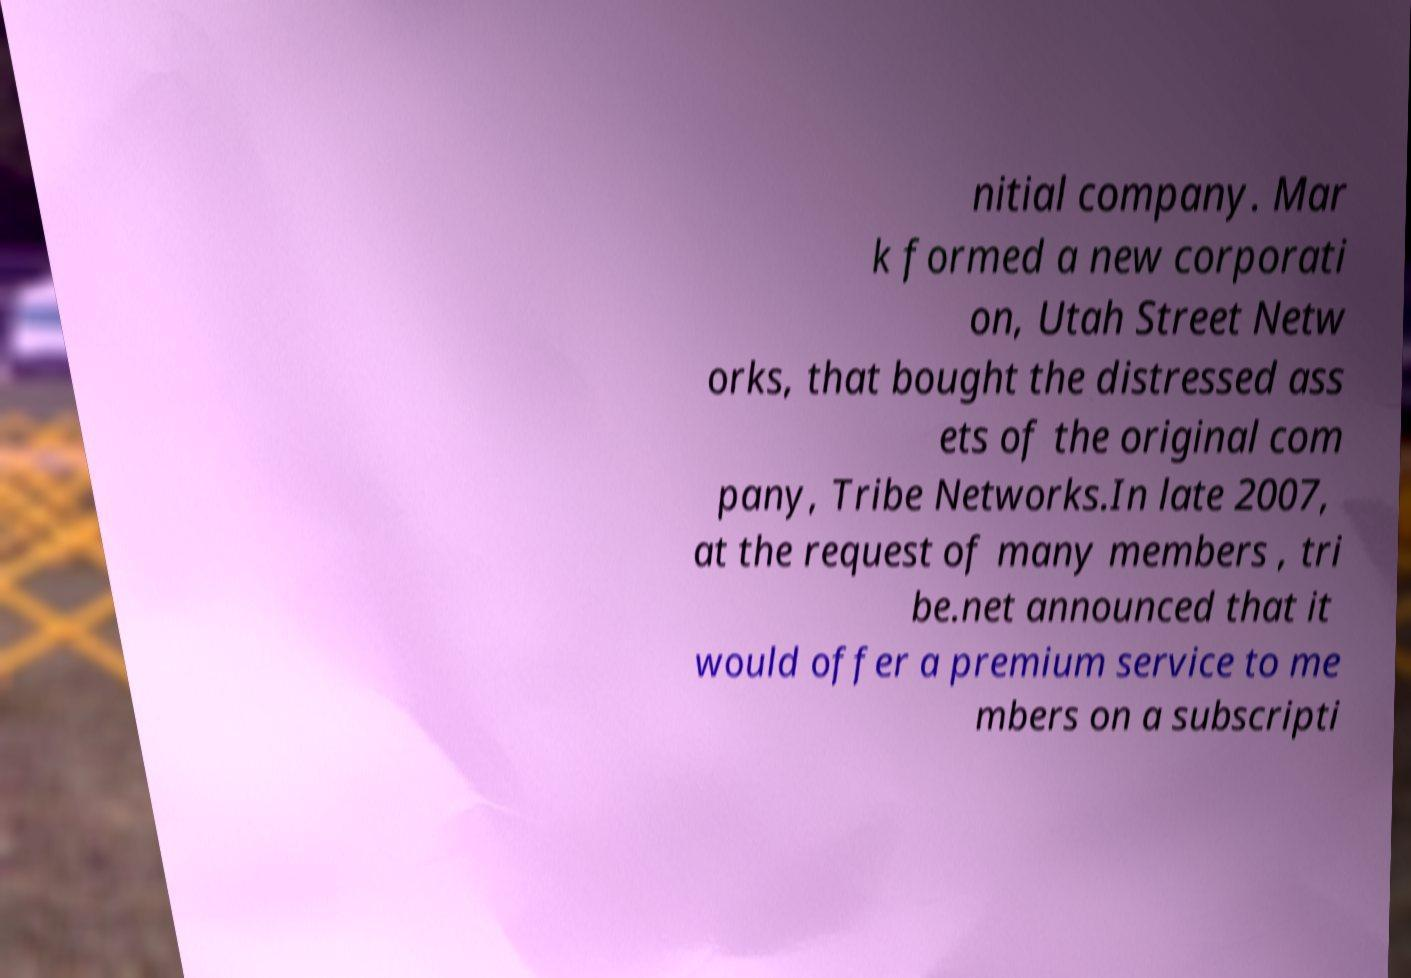What messages or text are displayed in this image? I need them in a readable, typed format. nitial company. Mar k formed a new corporati on, Utah Street Netw orks, that bought the distressed ass ets of the original com pany, Tribe Networks.In late 2007, at the request of many members , tri be.net announced that it would offer a premium service to me mbers on a subscripti 